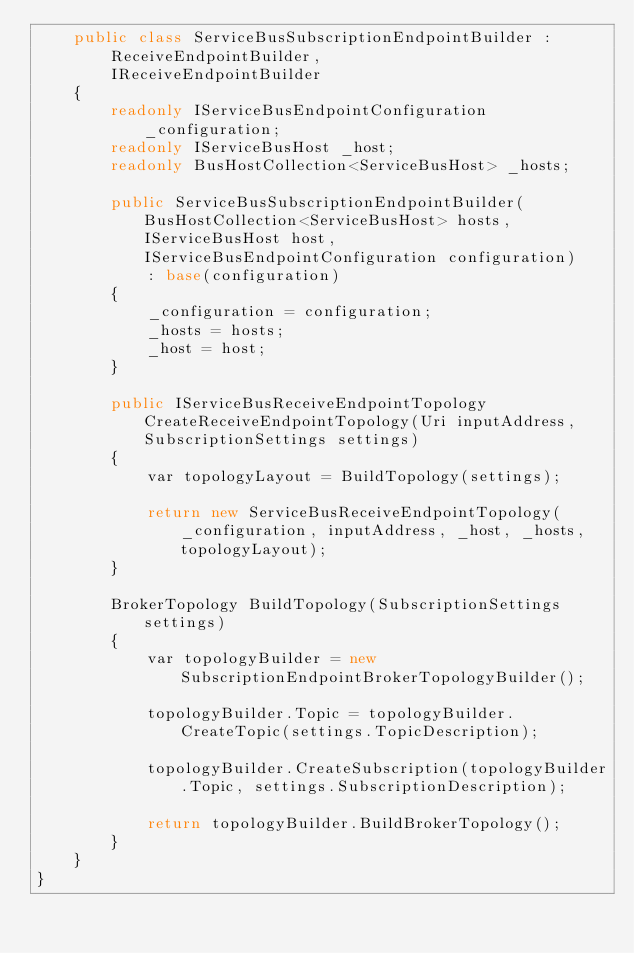Convert code to text. <code><loc_0><loc_0><loc_500><loc_500><_C#_>    public class ServiceBusSubscriptionEndpointBuilder :
        ReceiveEndpointBuilder,
        IReceiveEndpointBuilder
    {
        readonly IServiceBusEndpointConfiguration _configuration;
        readonly IServiceBusHost _host;
        readonly BusHostCollection<ServiceBusHost> _hosts;

        public ServiceBusSubscriptionEndpointBuilder(BusHostCollection<ServiceBusHost> hosts, IServiceBusHost host, IServiceBusEndpointConfiguration configuration)
            : base(configuration)
        {
            _configuration = configuration;
            _hosts = hosts;
            _host = host;
        }

        public IServiceBusReceiveEndpointTopology CreateReceiveEndpointTopology(Uri inputAddress, SubscriptionSettings settings)
        {
            var topologyLayout = BuildTopology(settings);

            return new ServiceBusReceiveEndpointTopology(_configuration, inputAddress, _host, _hosts, topologyLayout);
        }

        BrokerTopology BuildTopology(SubscriptionSettings settings)
        {
            var topologyBuilder = new SubscriptionEndpointBrokerTopologyBuilder();

            topologyBuilder.Topic = topologyBuilder.CreateTopic(settings.TopicDescription);

            topologyBuilder.CreateSubscription(topologyBuilder.Topic, settings.SubscriptionDescription);

            return topologyBuilder.BuildBrokerTopology();
        }
    }
}</code> 